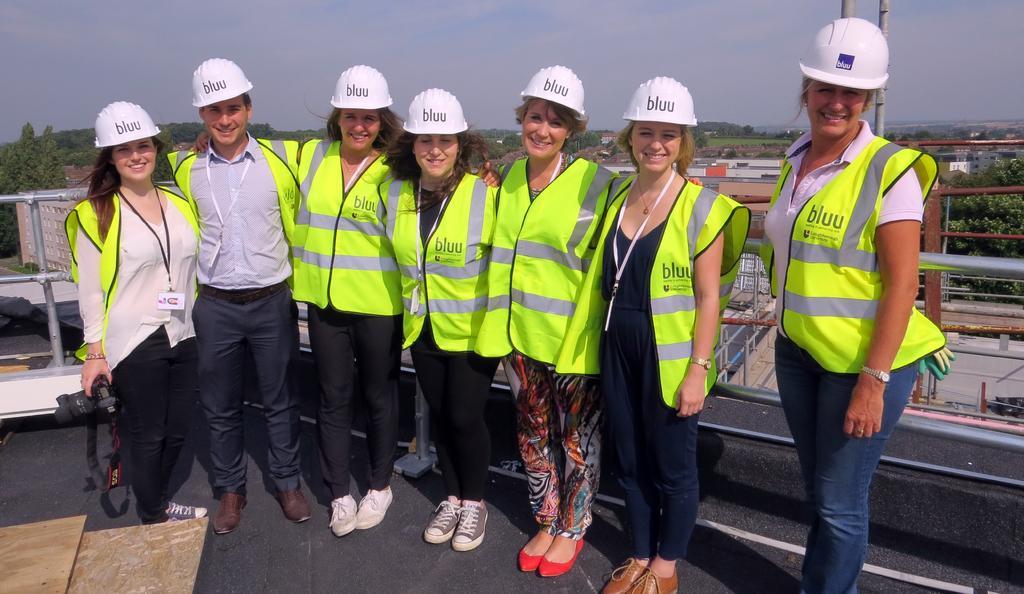Please provide a concise description of this image. This image consists of many persons wearing green color jackets. At the bottom, there is floor. Behind them, there is a railing. In the background, there are trees. At the top, there are clouds in the sky. 